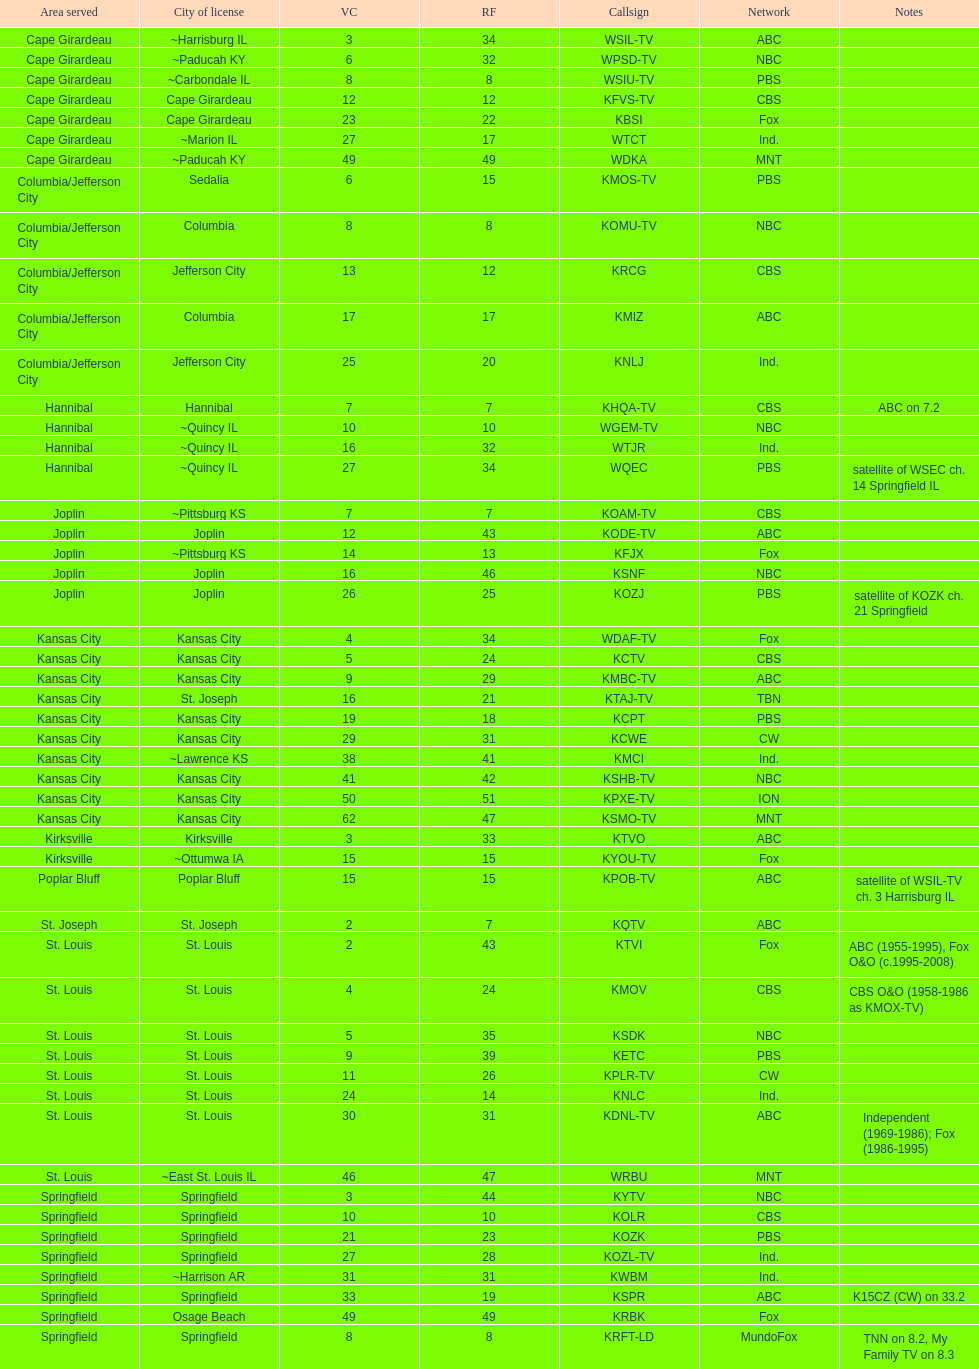What quantity of television networks provide service for the cape girardeau zone? 7. 